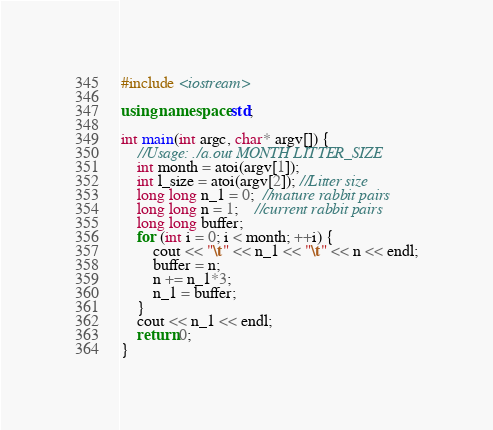Convert code to text. <code><loc_0><loc_0><loc_500><loc_500><_C++_>#include <iostream>

using namespace std;

int main(int argc, char* argv[]) {
    //Usage: ./a.out MONTH LITTER_SIZE
    int month = atoi(argv[1]);
    int l_size = atoi(argv[2]); //Litter size
    long long n_1 = 0;  //mature rabbit pairs
    long long n = 1;    //current rabbit pairs
    long long buffer;
    for (int i = 0; i < month; ++i) {
        cout << "\t" << n_1 << "\t" << n << endl;
        buffer = n;
        n += n_1*3;
        n_1 = buffer;
    }
    cout << n_1 << endl;
    return 0;
}
</code> 